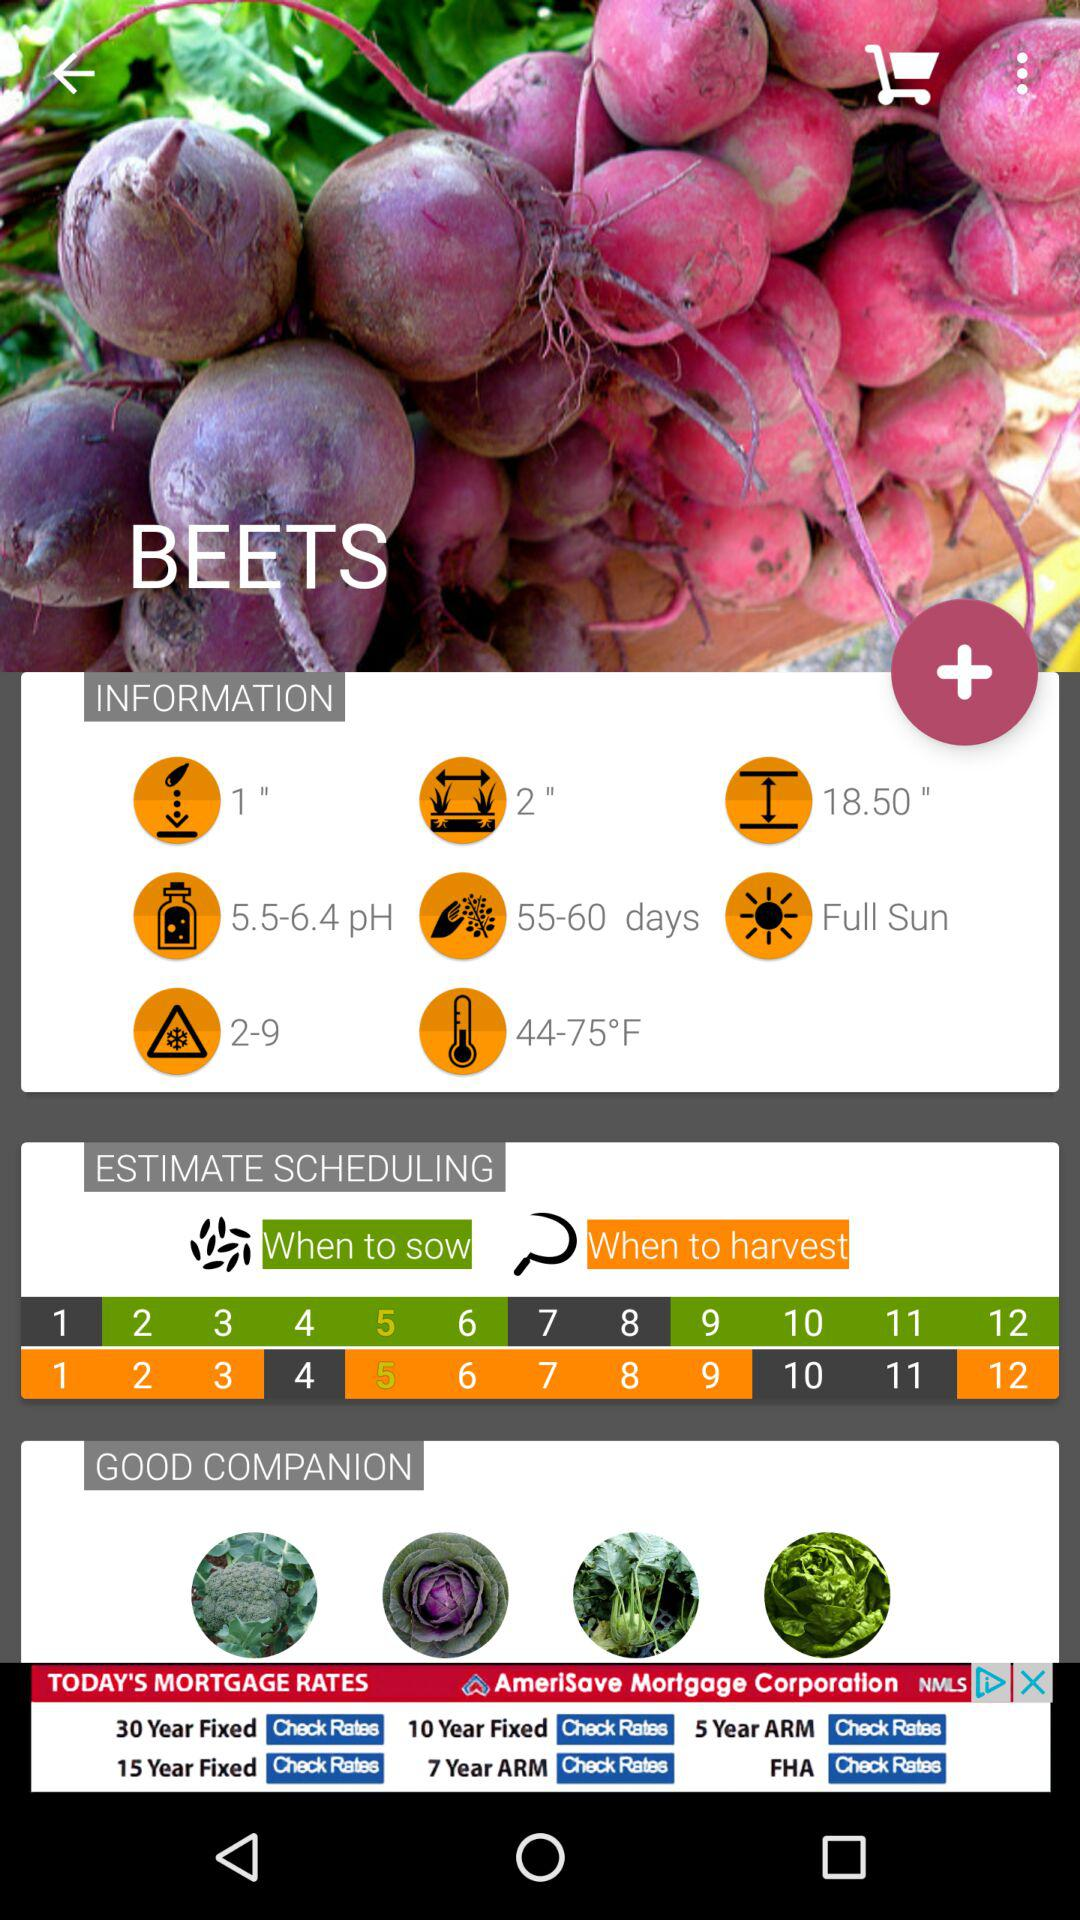How many days does it take for beets to grow?
Answer the question using a single word or phrase. 55-60 days 